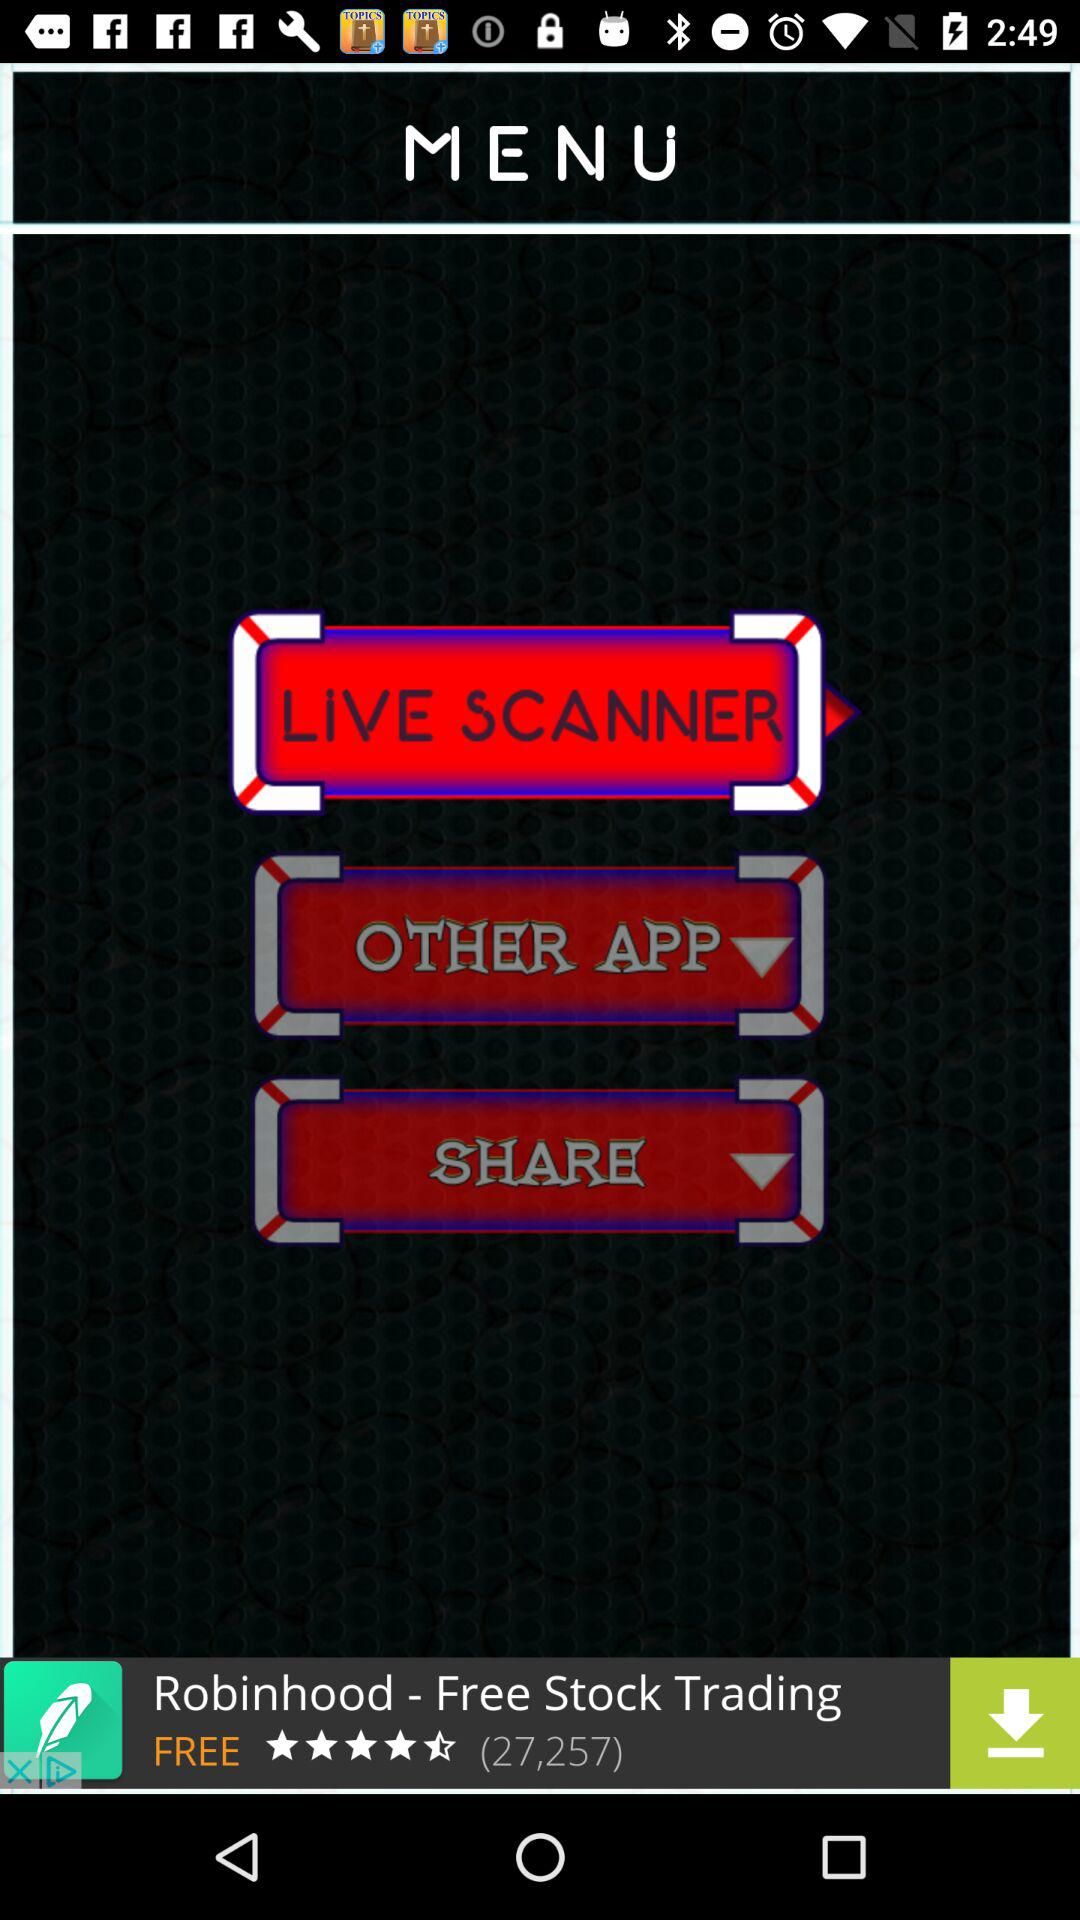Which option is selected? The selected option is "LIVE SCANNER". 